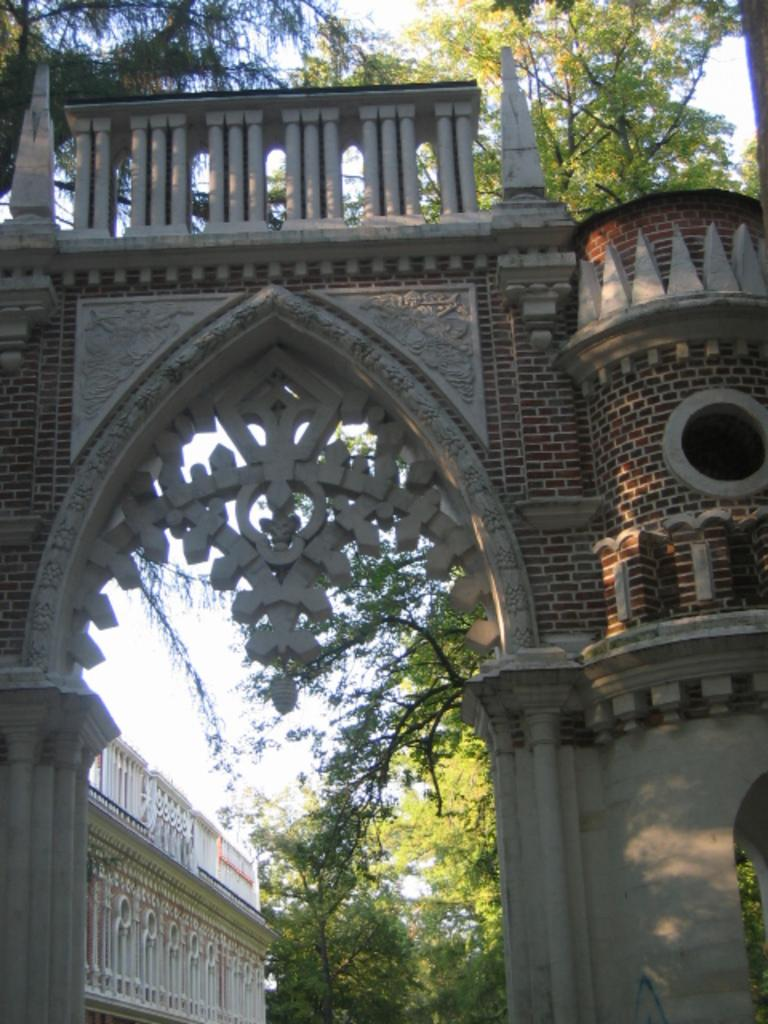What architectural feature is present in the image? There is an arch of a building in the image. What can be seen behind the arch? There is a group of trees visible behind the arch. What part of the natural environment is visible in the image? The sky is visible in the image. What type of hair can be seen on the table in the image? There is no hair or table present in the image; it features include an arch of a building, a group of trees, and the sky. 